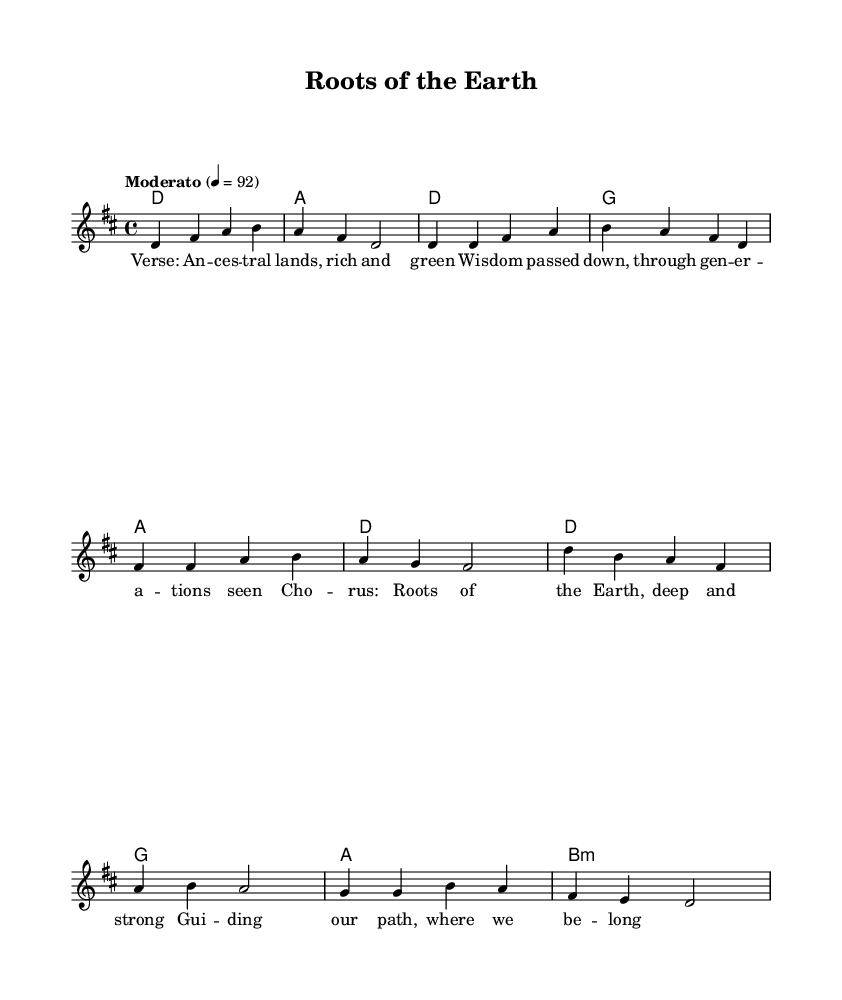What is the key signature of this music? The key signature is indicated at the beginning of the staff, which shows two sharps representing F# and C#. This indicates that the music is in the key of D major.
Answer: D major What is the time signature of this music? The time signature is found at the beginning of the staff and is marked as 4/4. This means there are four beats in each measure and the quarter note receives one beat.
Answer: 4/4 What is the tempo marking of this music? The tempo marking is shown above the staff as "Moderato" along with a specific metronome mark of 92, which indicates a moderate speed of performance.
Answer: Moderato 4 = 92 What is the name of the song? The title of the song is displayed at the top of the sheet music under the header section, which states "Roots of the Earth."
Answer: Roots of the Earth How many measures are in the verse section? The verse section includes a total of 8 measures, which can be counted from the beginning of the verse to its end, as visible in the melody and harmony lines.
Answer: 8 measures What are the lyrics of the chorus? The lyrics of the chorus are written under the melody, displaying "Roots of the Earth, deep and strong, Guiding our path, where we belong." This can be found after the verse section in the lyrics mode.
Answer: Roots of the Earth, deep and strong, Guiding our path, where we belong Which chords are used in the chorus? The chorus uses a sequence of chords, and by analyzing the chords indicated in the chord mode section, they include D, G, A, and B minor. This can be gathered from the symbols listed directly above the melody.
Answer: D, G, A, B minor 